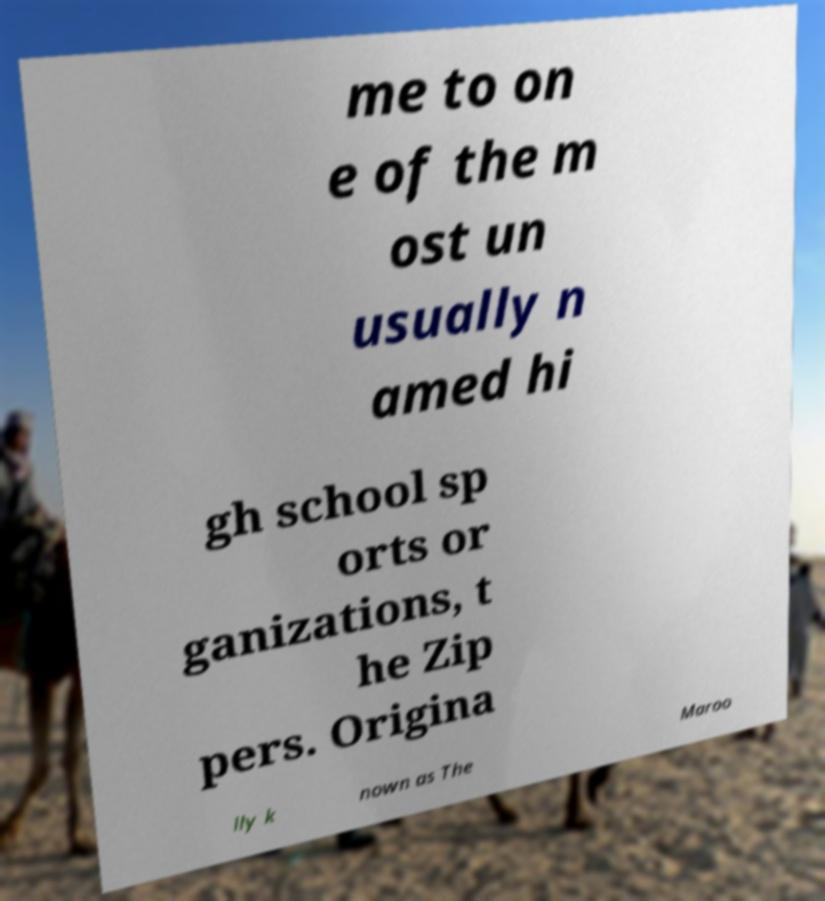For documentation purposes, I need the text within this image transcribed. Could you provide that? me to on e of the m ost un usually n amed hi gh school sp orts or ganizations, t he Zip pers. Origina lly k nown as The Maroo 